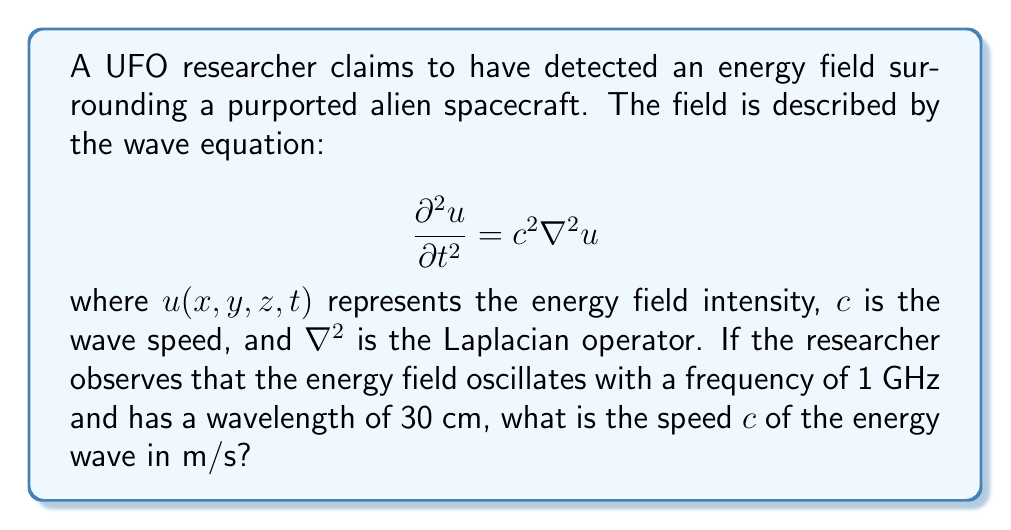Teach me how to tackle this problem. To solve this problem, we'll use the relationship between wave speed, frequency, and wavelength:

1) The wave equation given is the standard form for a 3D wave. The speed $c$ in this equation is what we need to find.

2) We're given two key pieces of information:
   - Frequency $f = 1$ GHz = $1 \times 10^9$ Hz
   - Wavelength $\lambda = 30$ cm = $0.3$ m

3) The relationship between wave speed, frequency, and wavelength is:

   $$c = f \lambda$$

4) Substituting our known values:

   $$c = (1 \times 10^9 \text{ Hz}) \times (0.3 \text{ m})$$

5) Calculating:

   $$c = 3 \times 10^8 \text{ m/s}$$

This speed is equal to the speed of light in vacuum, which could be interpreted as evidence for the advanced nature of the supposed alien technology, or as a sign that the researcher might be detecting electromagnetic radiation from a more mundane source.
Answer: $3 \times 10^8 \text{ m/s}$ 